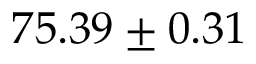<formula> <loc_0><loc_0><loc_500><loc_500>7 5 . 3 9 \pm 0 . 3 1</formula> 